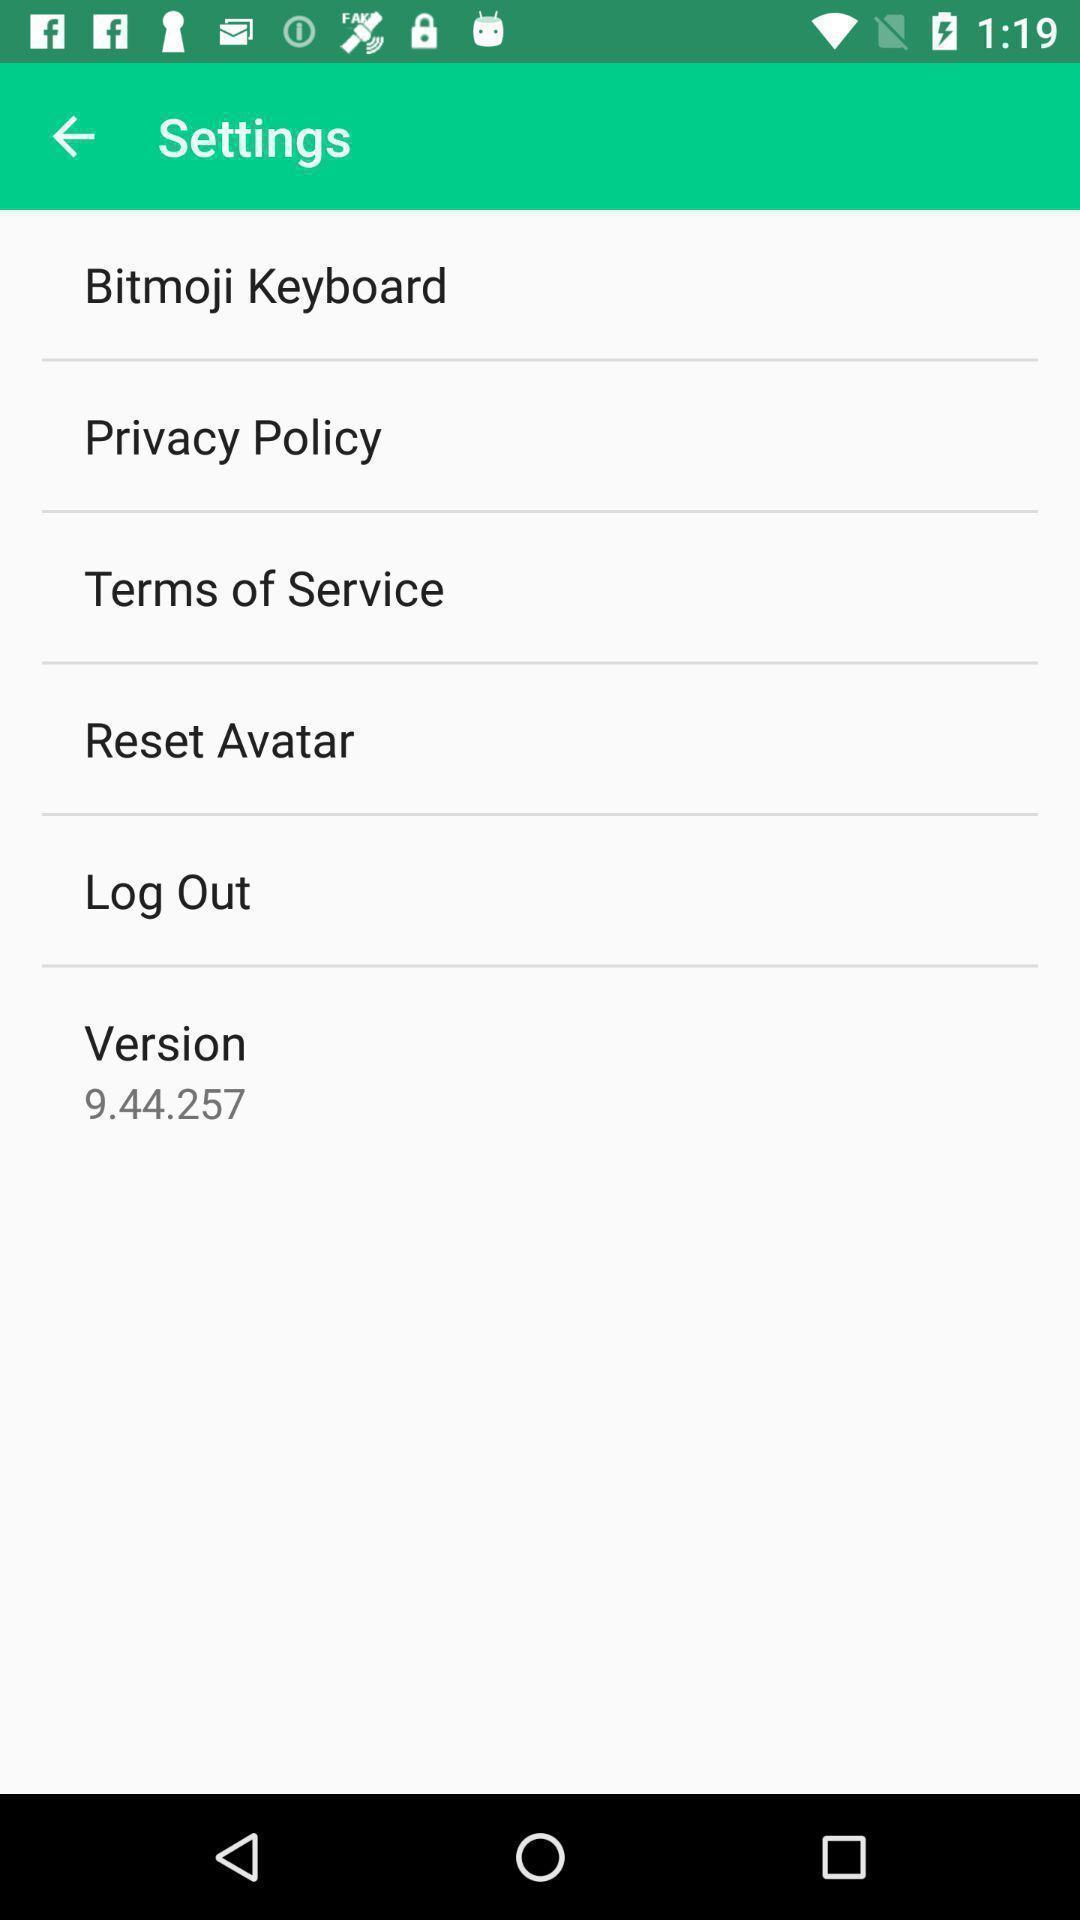Describe the content in this image. Settings page of an emoji app. 